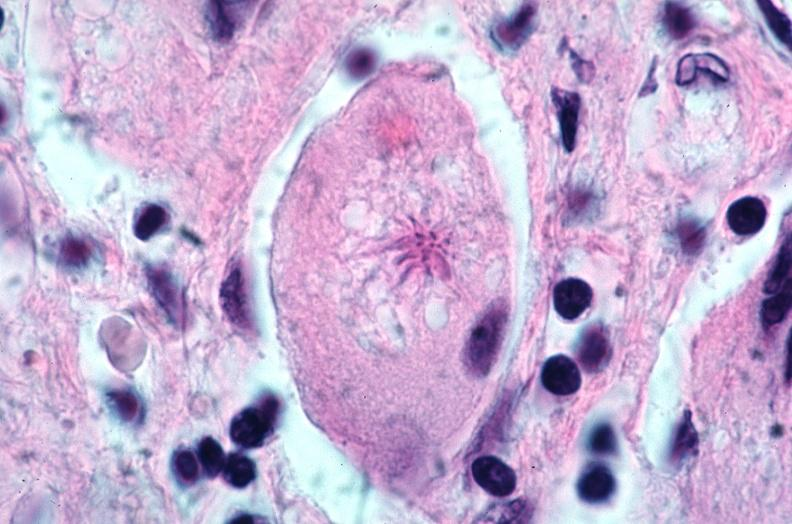what does this image show?
Answer the question using a single word or phrase. Lung 